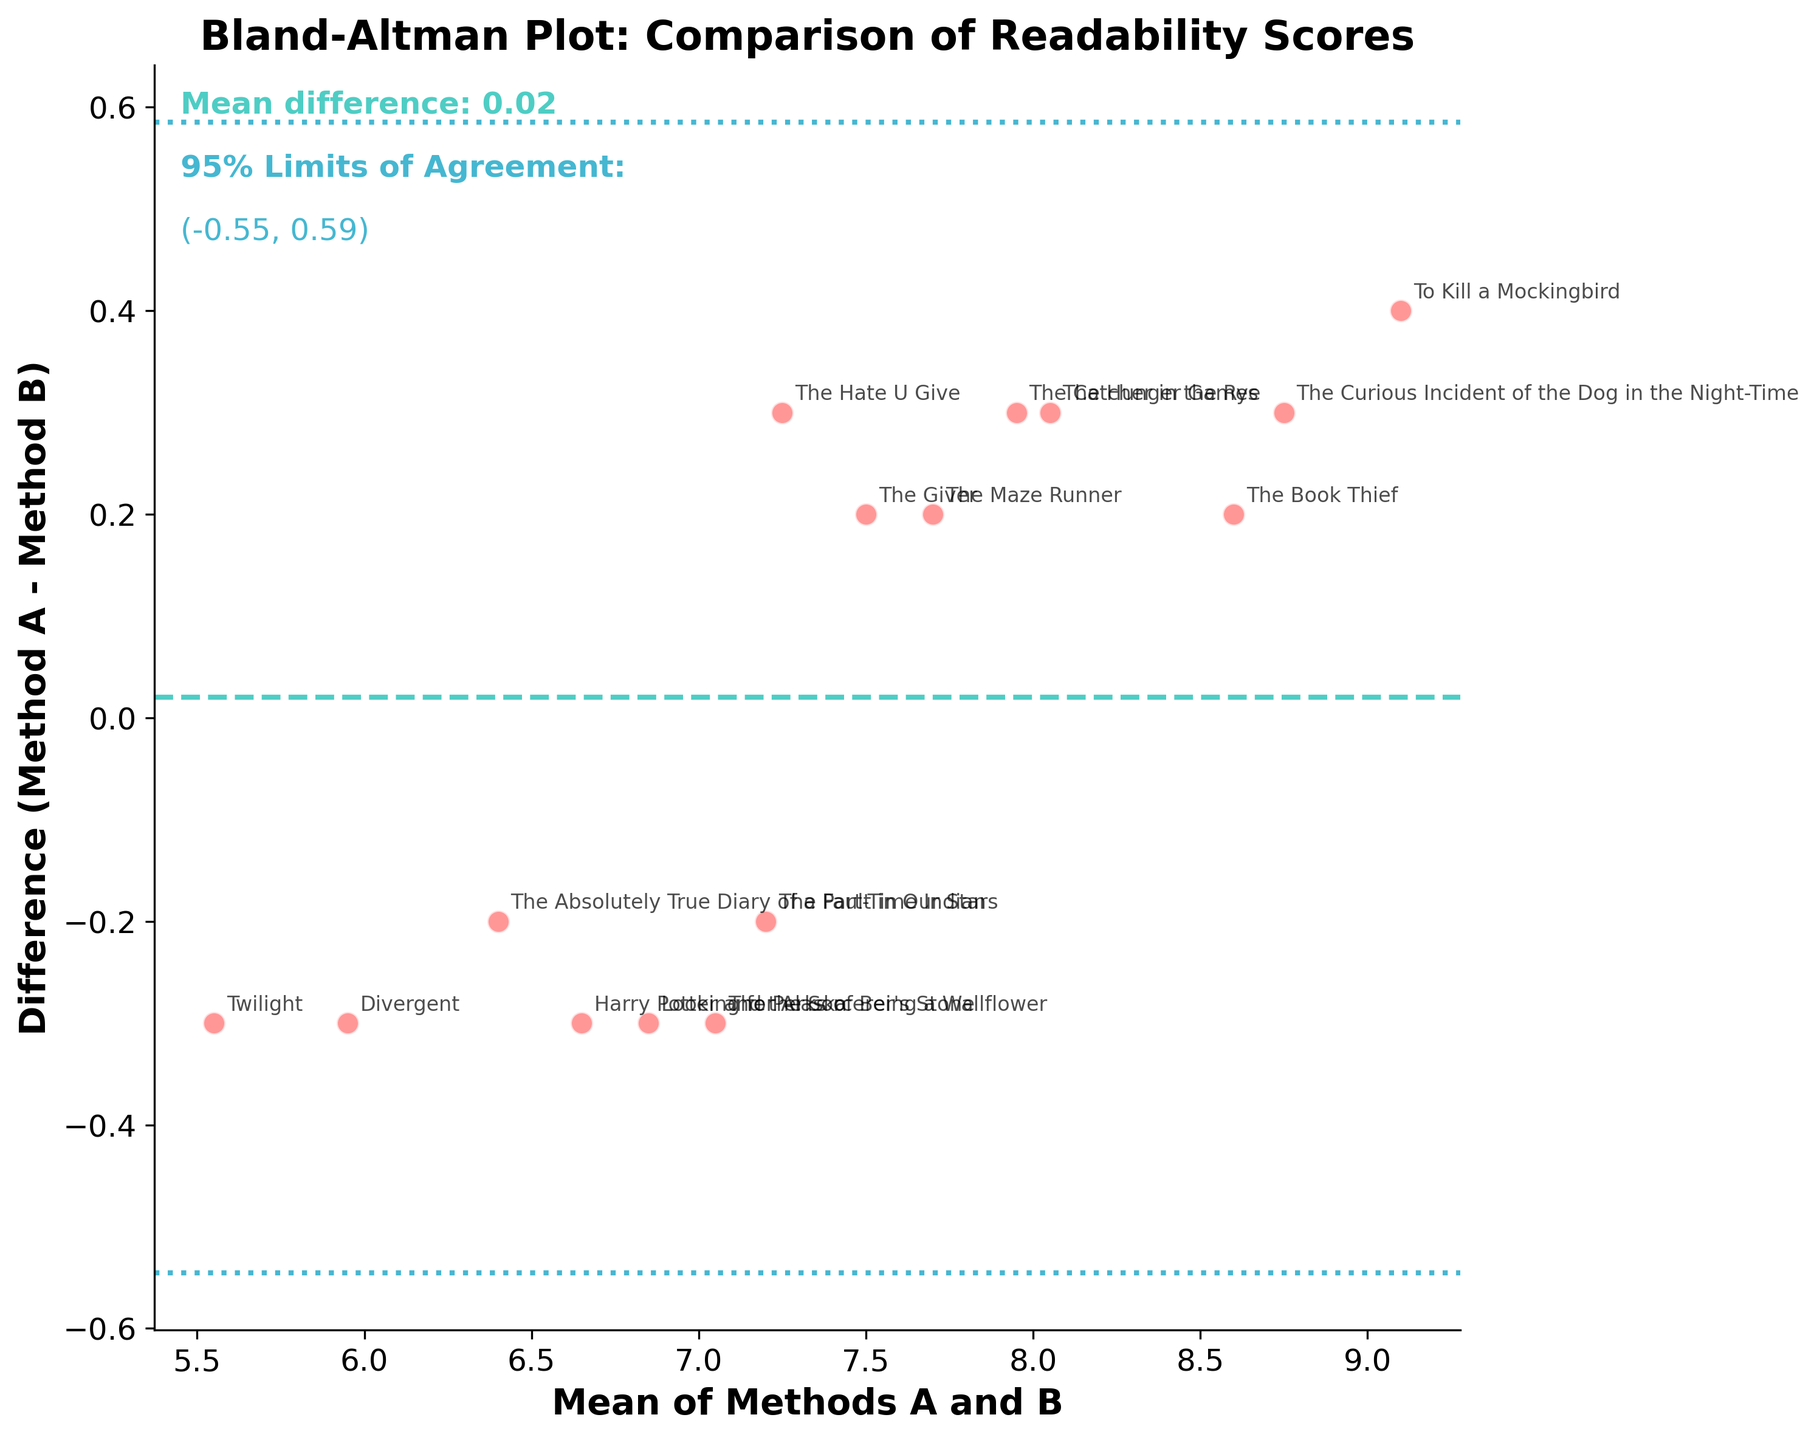What's the title of the plot? The title of the plot is typically found at the top of the figure in bold font. In this case, the title reads "Bland-Altman Plot: Comparison of Readability Scores".
Answer: Bland-Altman Plot: Comparison of Readability Scores How many data points are plotted in the figure? We can count the number of points on the scatter plot. Each point represents a book title. Counting them visually on the plot, there are 15 data points.
Answer: 15 What are the colors of the horizontal lines on the plot? There are three horizontal lines in the figure: one color distinguishable as turquoise represents the mean difference, and two other blue lines represent the limits of agreement. This can be seen from the colors in the legend text as well.
Answer: Turquoise and blue What's the mean difference between Method A and Method B? The mean difference is displayed on the plot itself, typically annotated near the mean difference line. It reads "Mean difference: -0.27".
Answer: -0.27 What is the range of the 95% limits of agreement on the plot? The 95% limits of agreement range is annotated near the respective blue lines on the plot. The text reads "95% Limits of Agreement: (-0.91, 0.37)".
Answer: (-0.91, 0.37) Which book has the highest mean readability score between Method A and Method B? To find this, we look at the points furthest to the right on the x-axis, which represents the mean. "To Kill a Mockingbird" is the rightmost point in the figure.
Answer: To Kill a Mockingbird Which book shows the greatest readability difference between Method A and Method B? The book with the greatest readability difference will be the one with the highest absolute difference value along the y-axis. "To Kill a Mockingbird" has the largest positive difference.
Answer: To Kill a Mockingbird Are there any points outside the limits of agreement? We need to check if any points fall outside the blue lines representing the limits of agreement. None of the points cross these lines on the figure.
Answer: No What's the average of the mean readability scores for "Twilight" and "The Maze Runner"? The mean readability score for "Twilight" is plotted at around 5.55 and for "The Maze Runner" around 7.7. The average can be calculated as (5.55 + 7.7) / 2 = 6.625.
Answer: 6.625 Which method tends to give higher readability scores overall, and how can you tell? By observing the direction and position of most data points relative to the mean difference line. The majority of points lie above the zero line, indicating Method B generally gives higher scores.
Answer: Method B 